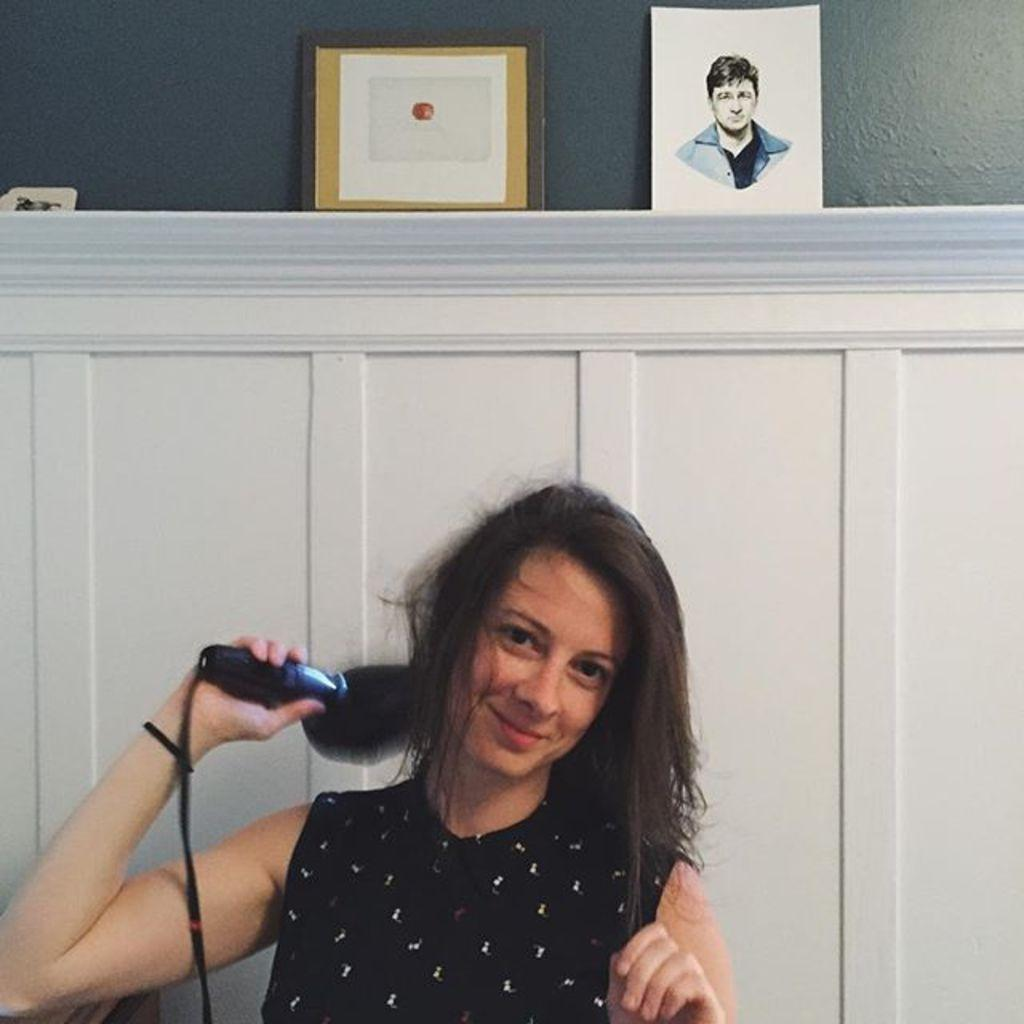Who is present in the image? There is a lady in the image. What is the lady holding in the image? The lady is holding a hair dryer. What objects can be seen on the wooden table in the image? There are two photo frames on a wooden table in the image. What can be seen in the background of the image? There is a wall visible in the image. What type of meat is being prepared on the wall in the image? There is no meat or any indication of food preparation in the image; it features a lady holding a hair dryer and photo frames on a wooden table. 